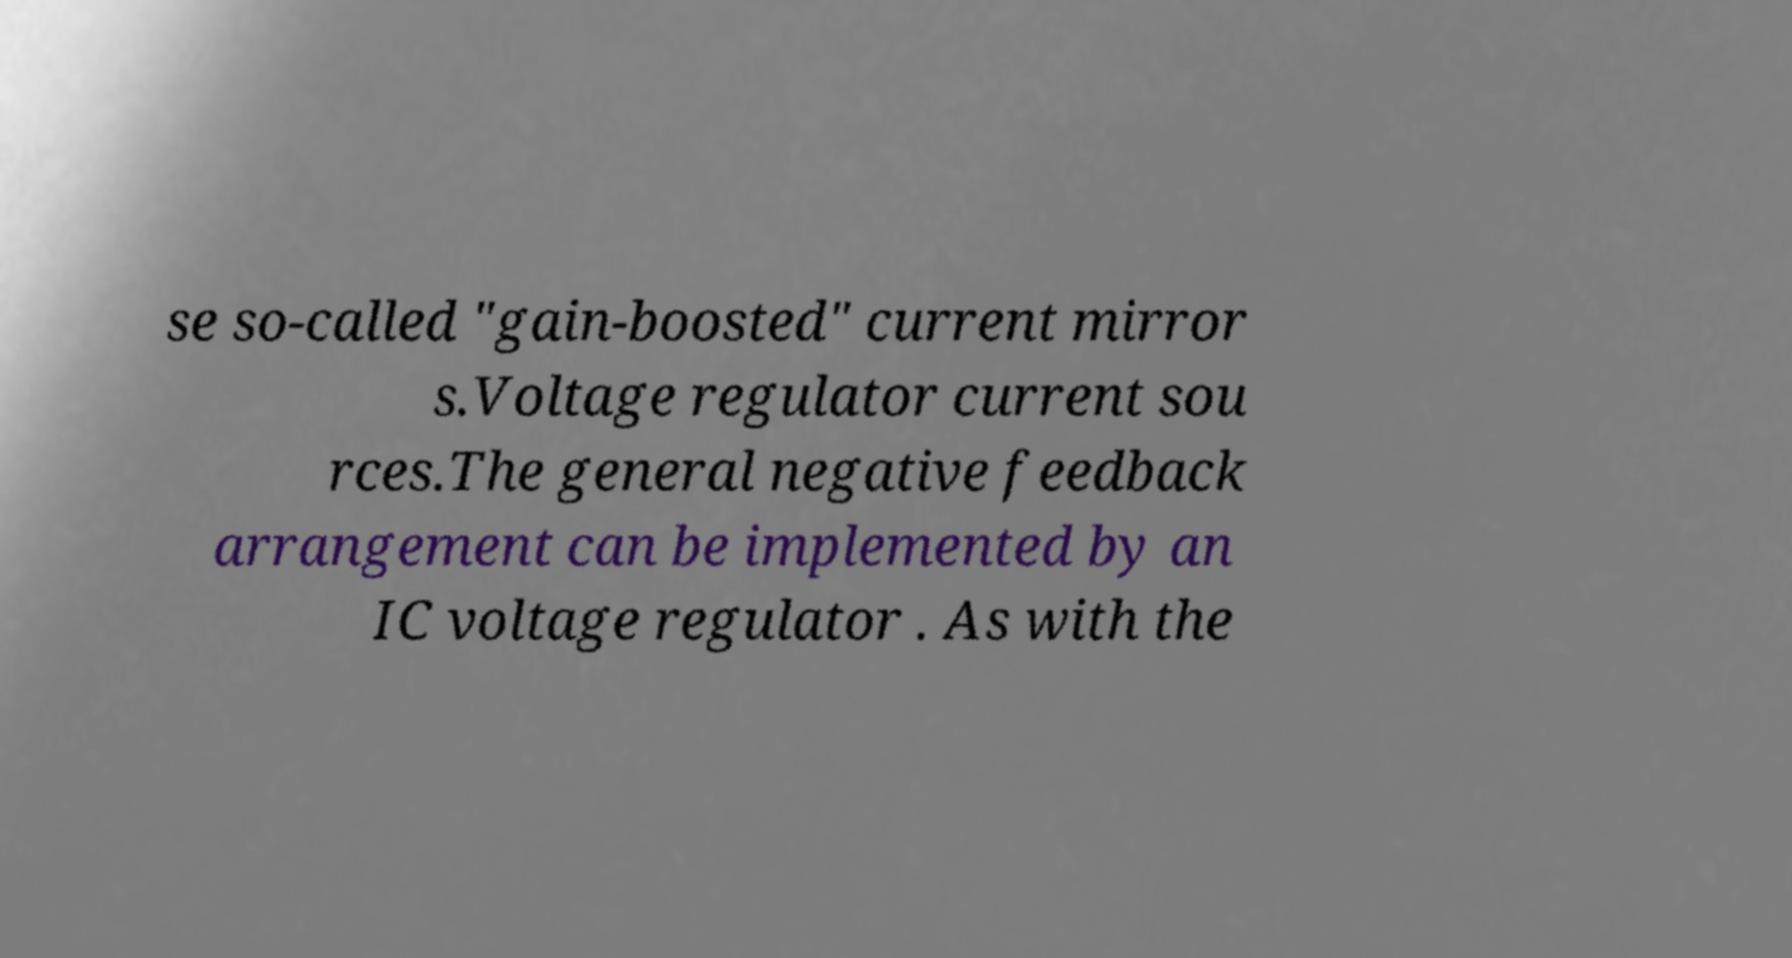For documentation purposes, I need the text within this image transcribed. Could you provide that? se so-called "gain-boosted" current mirror s.Voltage regulator current sou rces.The general negative feedback arrangement can be implemented by an IC voltage regulator . As with the 